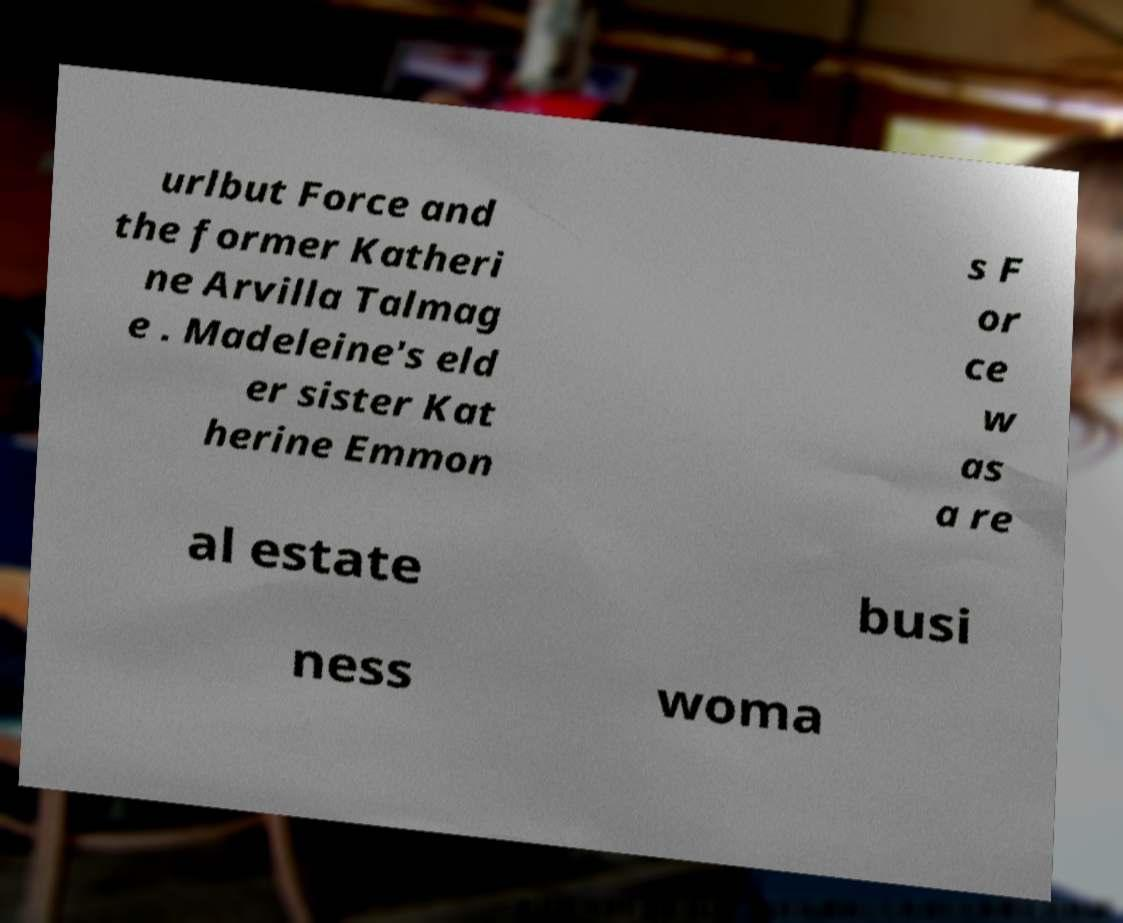What messages or text are displayed in this image? I need them in a readable, typed format. urlbut Force and the former Katheri ne Arvilla Talmag e . Madeleine's eld er sister Kat herine Emmon s F or ce w as a re al estate busi ness woma 